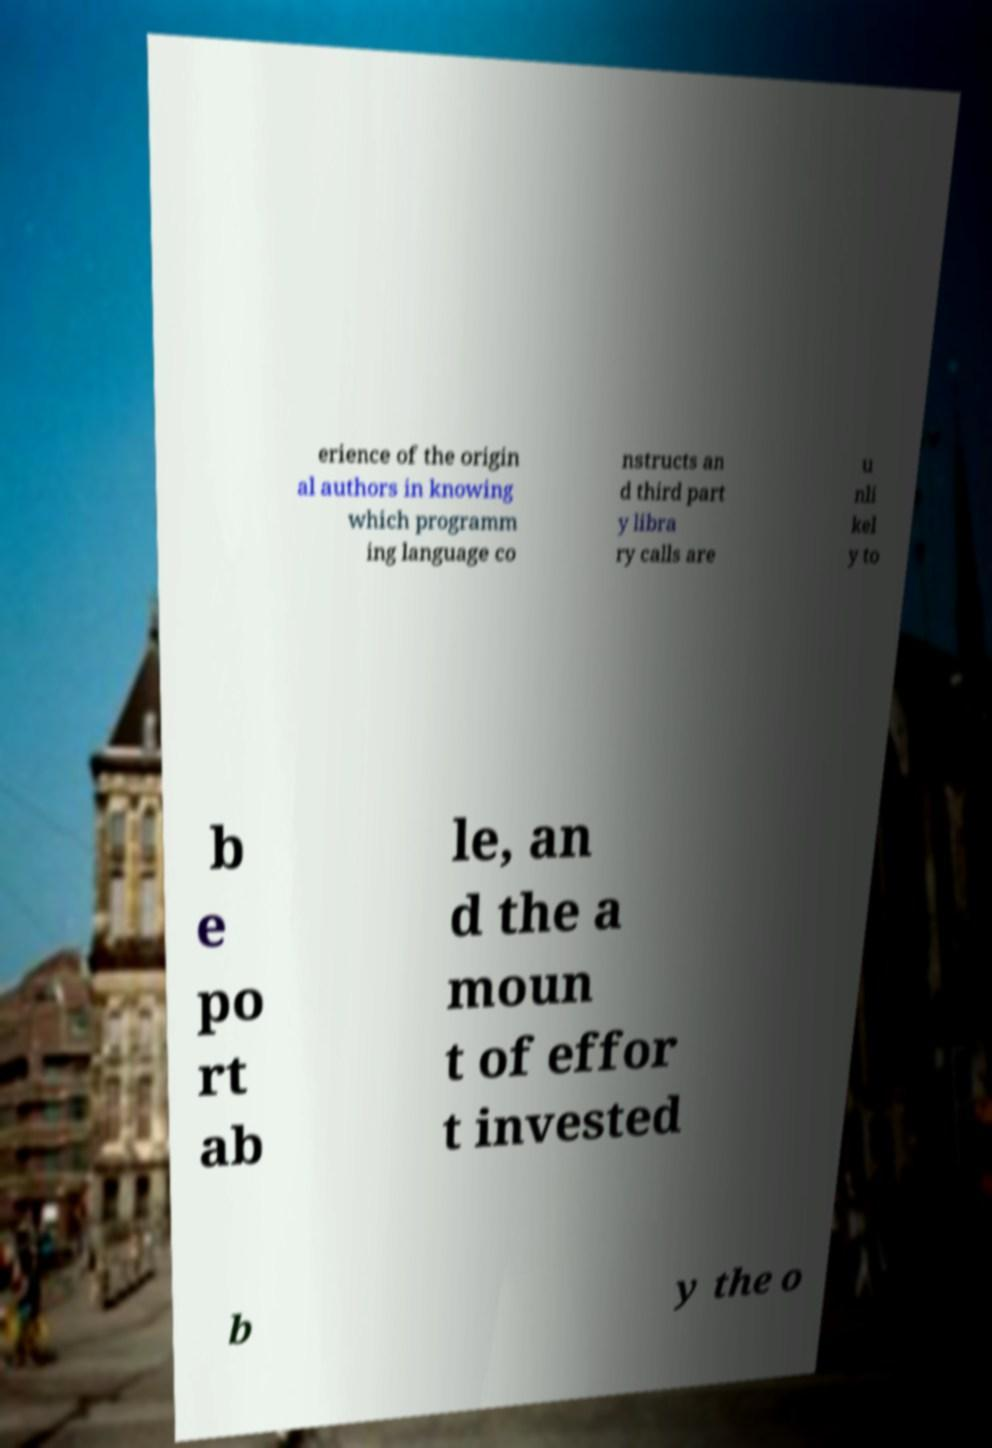Could you extract and type out the text from this image? erience of the origin al authors in knowing which programm ing language co nstructs an d third part y libra ry calls are u nli kel y to b e po rt ab le, an d the a moun t of effor t invested b y the o 